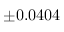<formula> <loc_0><loc_0><loc_500><loc_500>\pm 0 . 0 4 0 4</formula> 